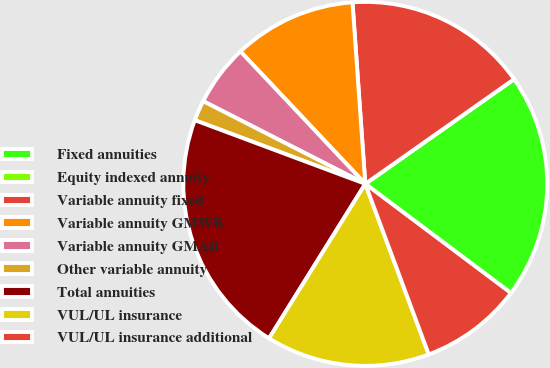Convert chart. <chart><loc_0><loc_0><loc_500><loc_500><pie_chart><fcel>Fixed annuities<fcel>Equity indexed annuity<fcel>Variable annuity fixed<fcel>Variable annuity GMWB<fcel>Variable annuity GMAB<fcel>Other variable annuity<fcel>Total annuities<fcel>VUL/UL insurance<fcel>VUL/UL insurance additional<nl><fcel>20.0%<fcel>0.0%<fcel>16.36%<fcel>10.91%<fcel>5.46%<fcel>1.82%<fcel>21.82%<fcel>14.54%<fcel>9.09%<nl></chart> 